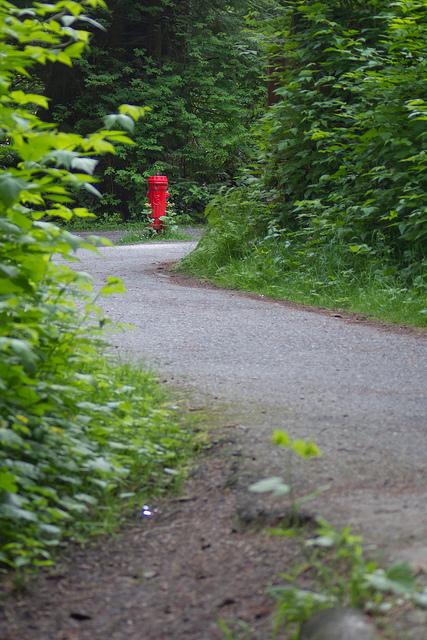Is there a bike in the picture?
Answer briefly. No. What is the only red object in the photo?
Answer briefly. Fire hydrant. Do you see a road?
Write a very short answer. Yes. What is the path made out of?
Give a very brief answer. Gravel. Is the camera height tall or short?
Give a very brief answer. Short. How many cars are parked across the street?
Quick response, please. 0. 